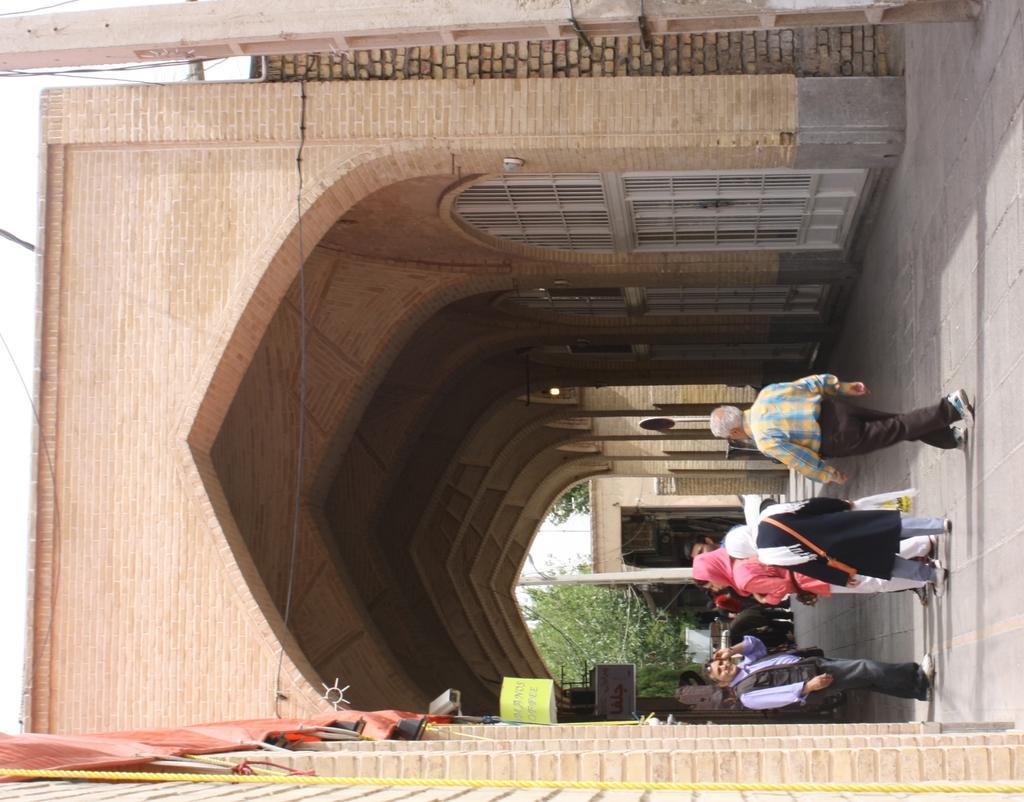In one or two sentences, can you explain what this image depicts? In this image I can see some people on the road. I can see the arch. 